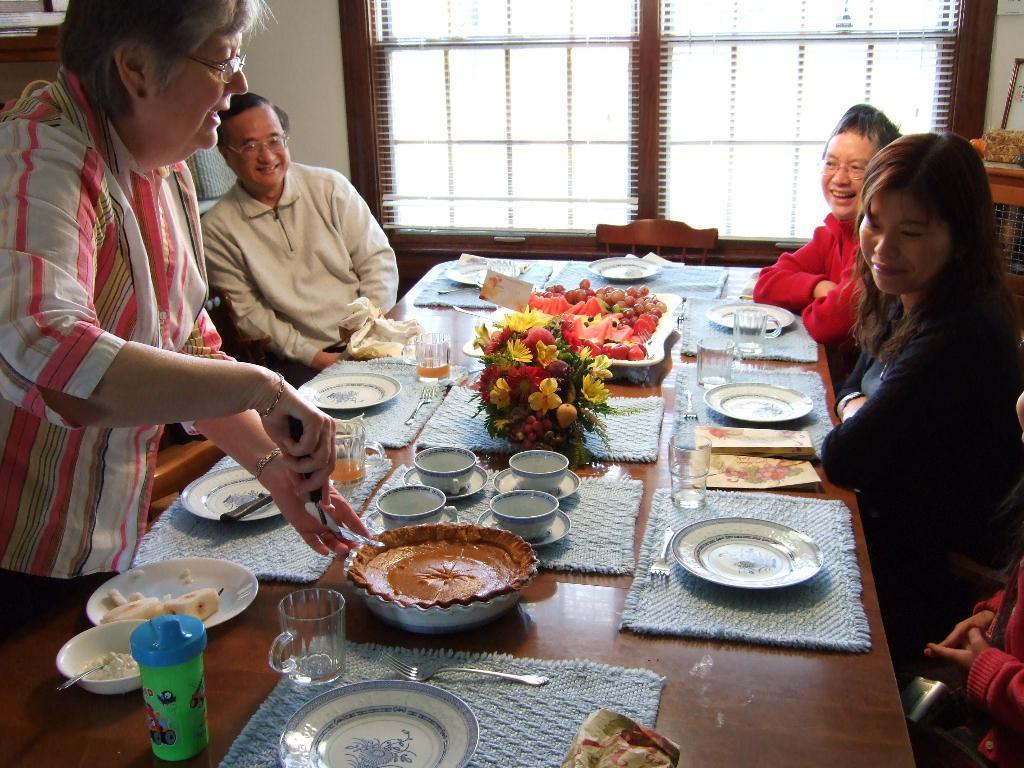Can you describe this image briefly? These three persons are sitting on chairs and smiling. In-front of them there is a table, on this table there is a plate, bowl, cups, glasses, plant, cloth and food. This woman is standing and holding this bowl. Beside this person's there is a window. 